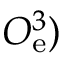<formula> <loc_0><loc_0><loc_500><loc_500>O _ { e } ^ { 3 } )</formula> 